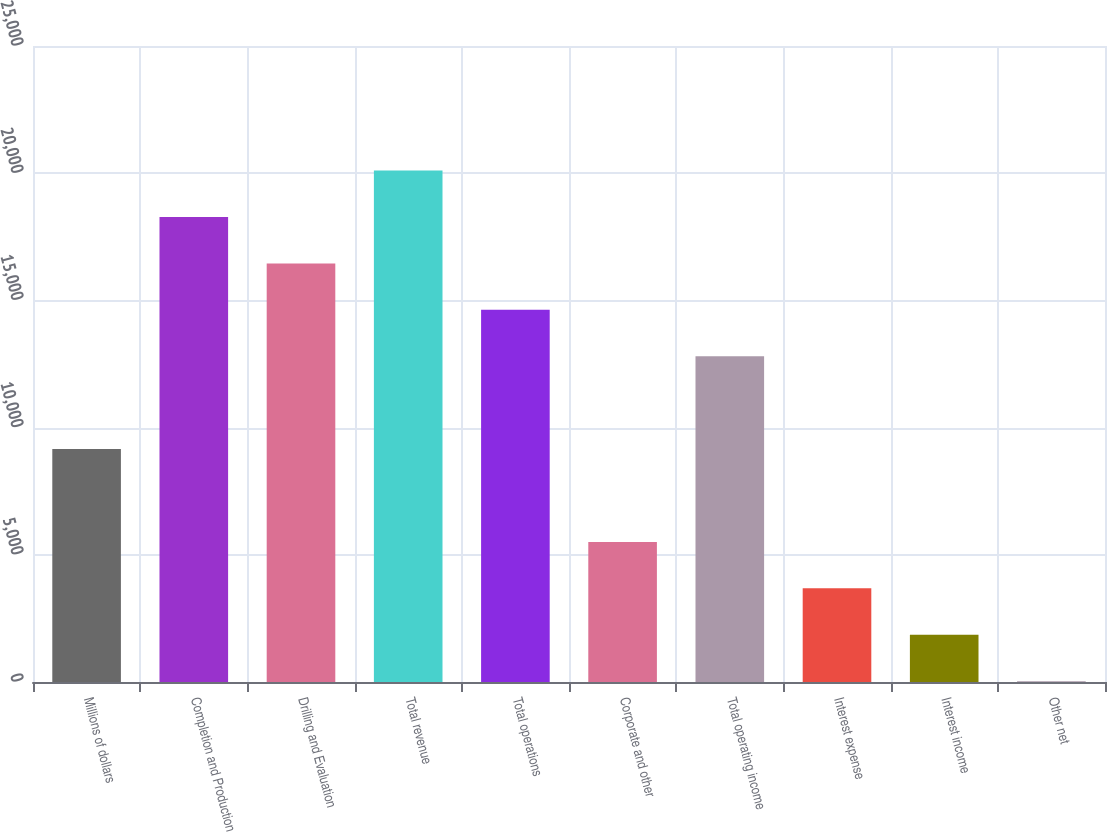<chart> <loc_0><loc_0><loc_500><loc_500><bar_chart><fcel>Millions of dollars<fcel>Completion and Production<fcel>Drilling and Evaluation<fcel>Total revenue<fcel>Total operations<fcel>Corporate and other<fcel>Total operating income<fcel>Interest expense<fcel>Interest income<fcel>Other net<nl><fcel>9156<fcel>18279<fcel>16454.4<fcel>20103.6<fcel>14629.8<fcel>5506.8<fcel>12805.2<fcel>3682.2<fcel>1857.6<fcel>33<nl></chart> 